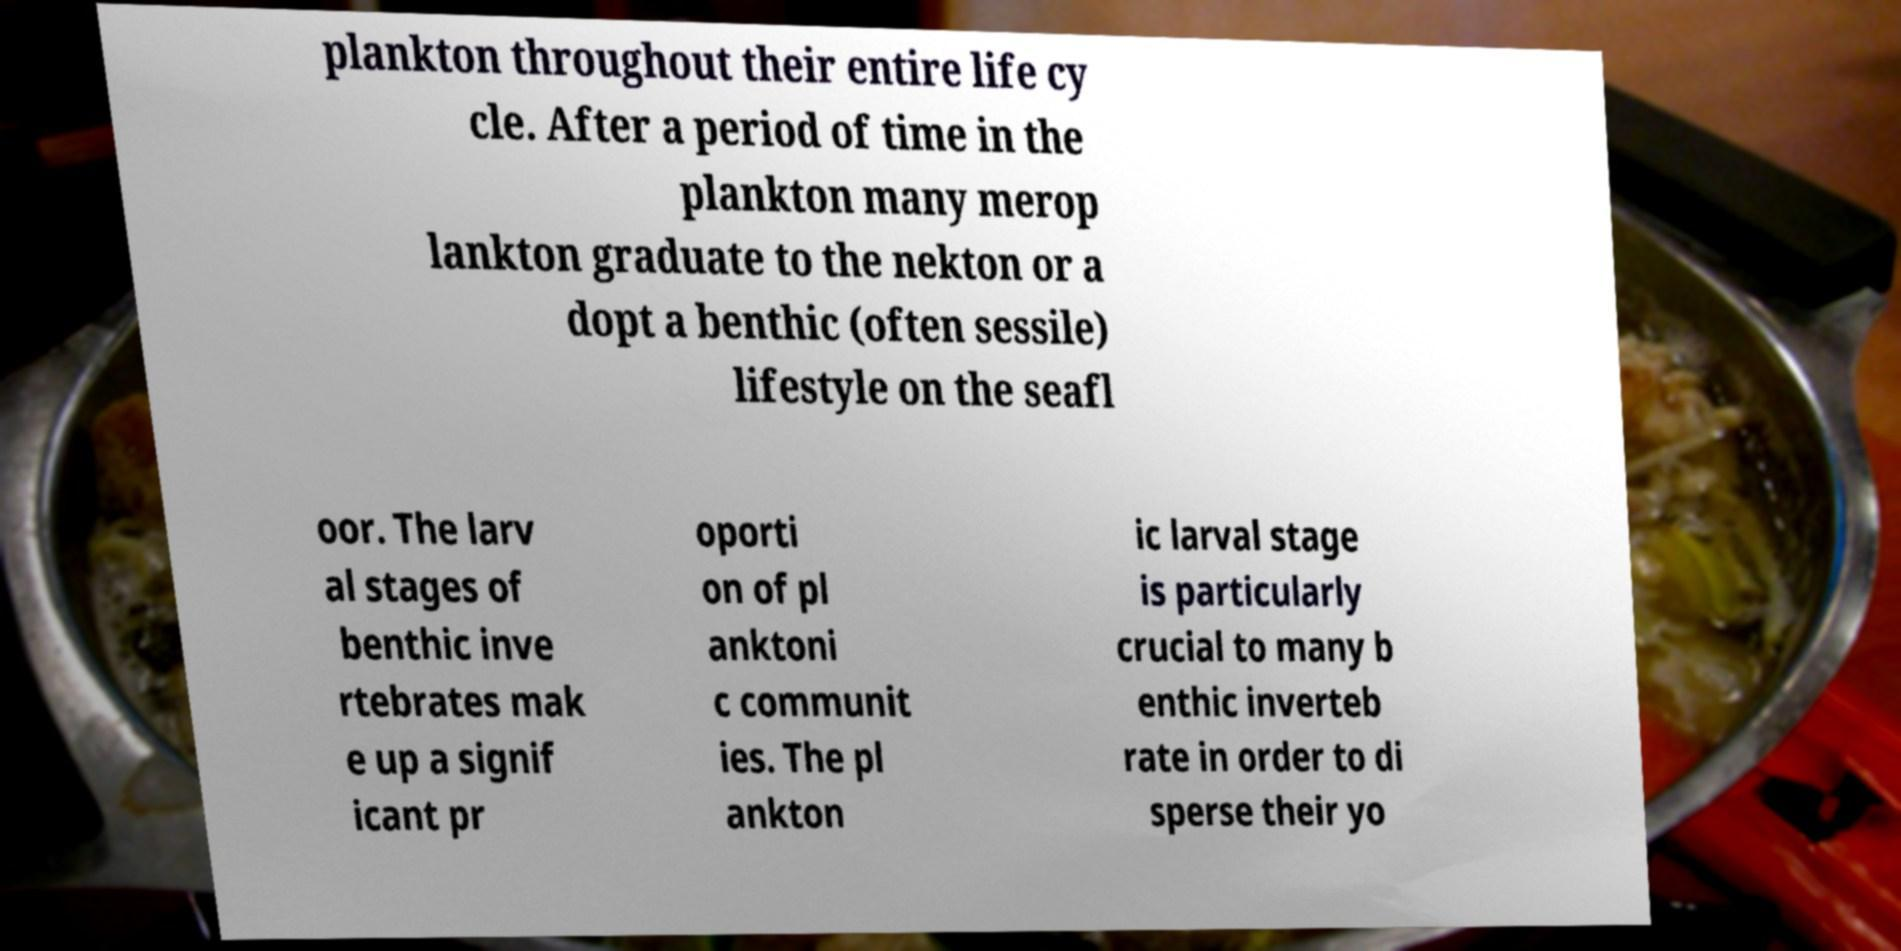There's text embedded in this image that I need extracted. Can you transcribe it verbatim? plankton throughout their entire life cy cle. After a period of time in the plankton many merop lankton graduate to the nekton or a dopt a benthic (often sessile) lifestyle on the seafl oor. The larv al stages of benthic inve rtebrates mak e up a signif icant pr oporti on of pl anktoni c communit ies. The pl ankton ic larval stage is particularly crucial to many b enthic inverteb rate in order to di sperse their yo 